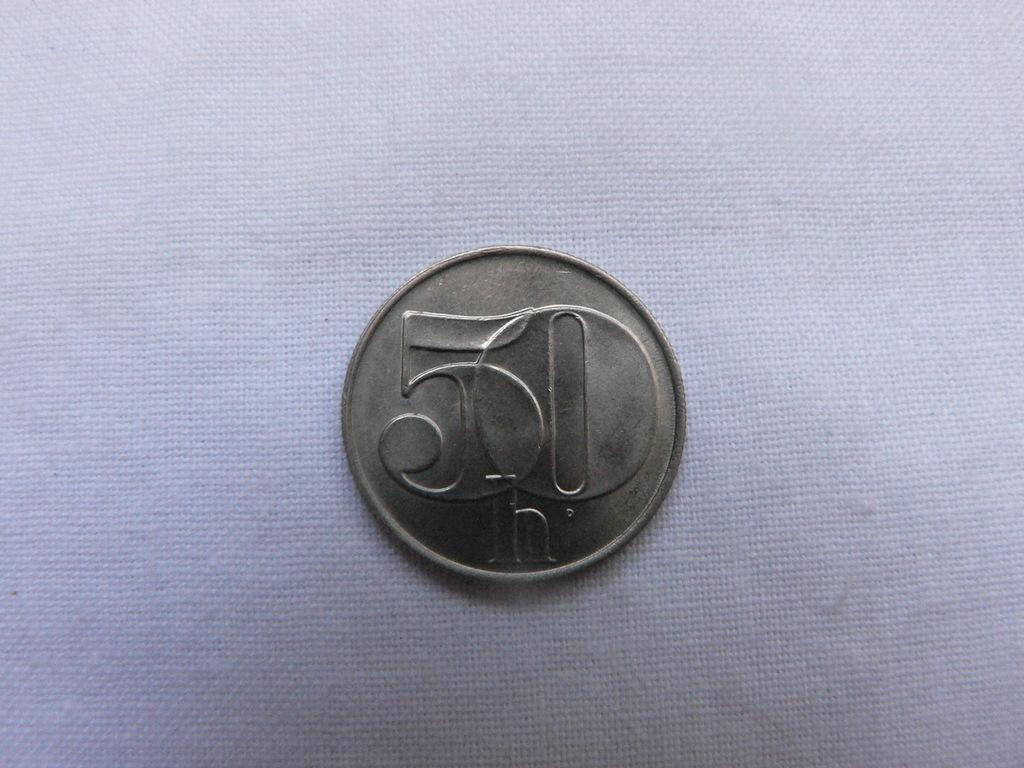What number is on the coin?
Your answer should be compact. 50. What is the letter at the bottom of the coin?
Ensure brevity in your answer.  H. 